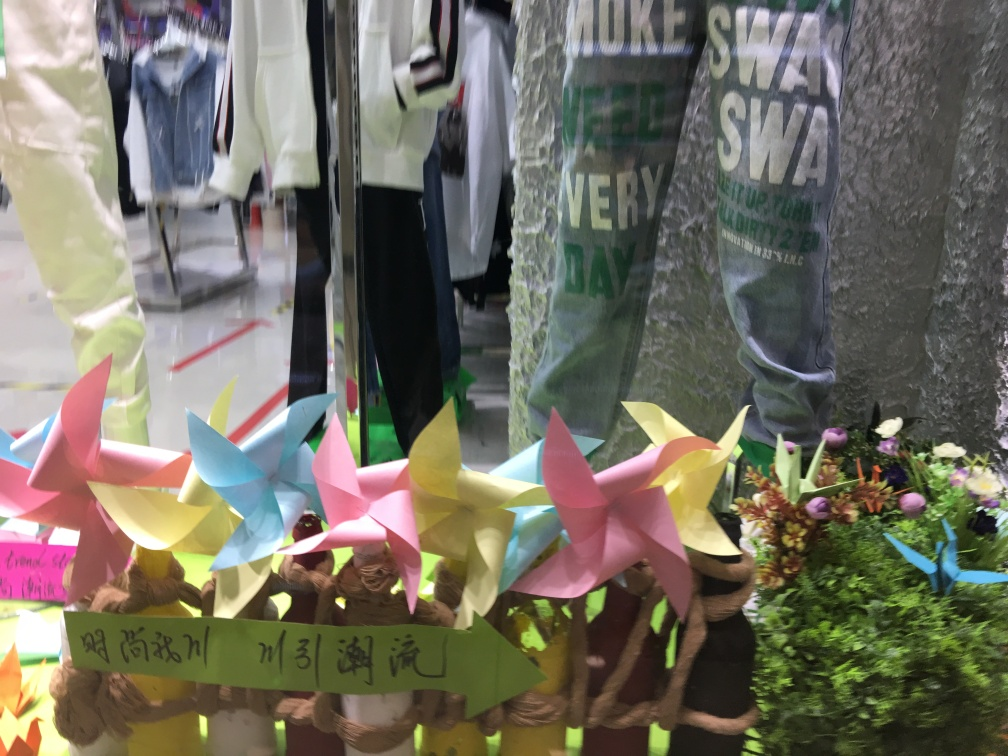Can you tell me more about the pinwheels in the image? The pinwheels displayed in the image add a whimsical and playful touch. They are made of paper in various colors and appear handcrafted. Typically, pinwheels symbolize childhood innocence and the turning points in life, often used in celebrations or as decoration. 